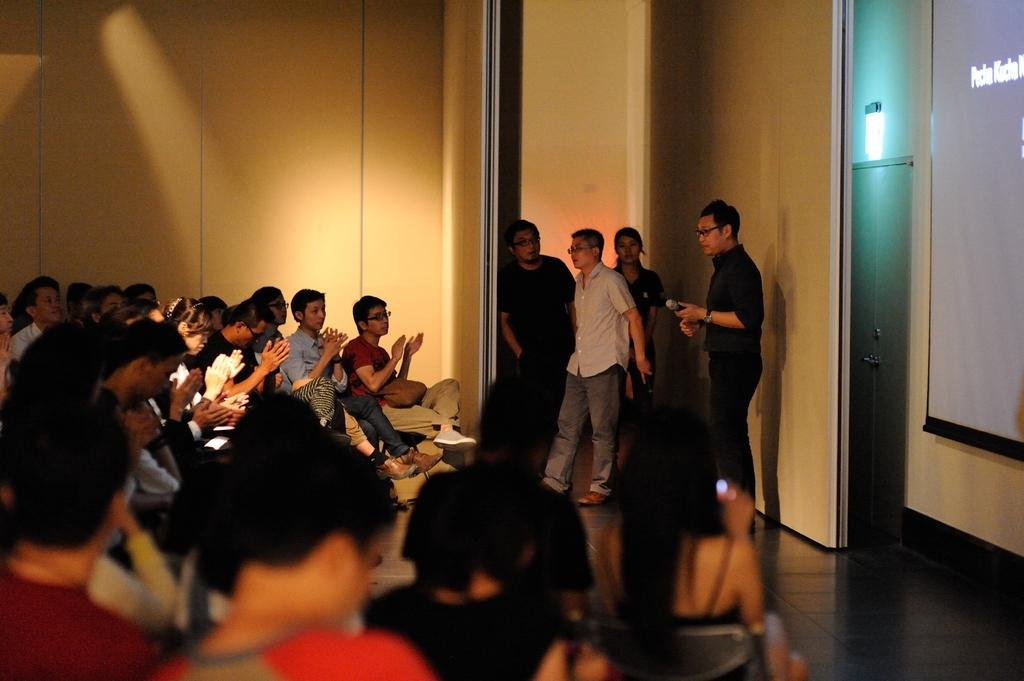What are the people in the image doing? There are people sitting and standing in the image. Can you describe the boy in the image? The boy is standing and holding a microphone. What is visible in the background of the image? There is a wall visible in the image. What is the price of the station the boy is standing on in the image? There is no station present in the image, and therefore no price can be determined. 